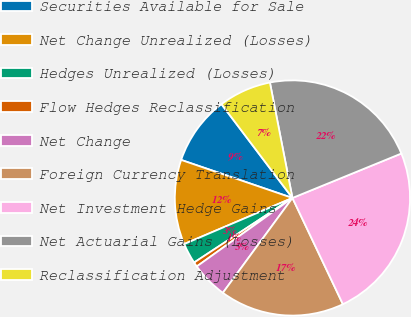Convert chart. <chart><loc_0><loc_0><loc_500><loc_500><pie_chart><fcel>Securities Available for Sale<fcel>Net Change Unrealized (Losses)<fcel>Hedges Unrealized (Losses)<fcel>Flow Hedges Reclassification<fcel>Net Change<fcel>Foreign Currency Translation<fcel>Net Investment Hedge Gains<fcel>Net Actuarial Gains (Losses)<fcel>Reclassification Adjustment<nl><fcel>9.45%<fcel>11.65%<fcel>2.84%<fcel>0.64%<fcel>5.04%<fcel>17.13%<fcel>24.11%<fcel>21.9%<fcel>7.24%<nl></chart> 